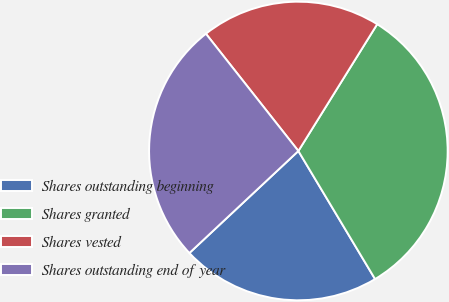Convert chart to OTSL. <chart><loc_0><loc_0><loc_500><loc_500><pie_chart><fcel>Shares outstanding beginning<fcel>Shares granted<fcel>Shares vested<fcel>Shares outstanding end of year<nl><fcel>21.61%<fcel>32.56%<fcel>19.48%<fcel>26.35%<nl></chart> 